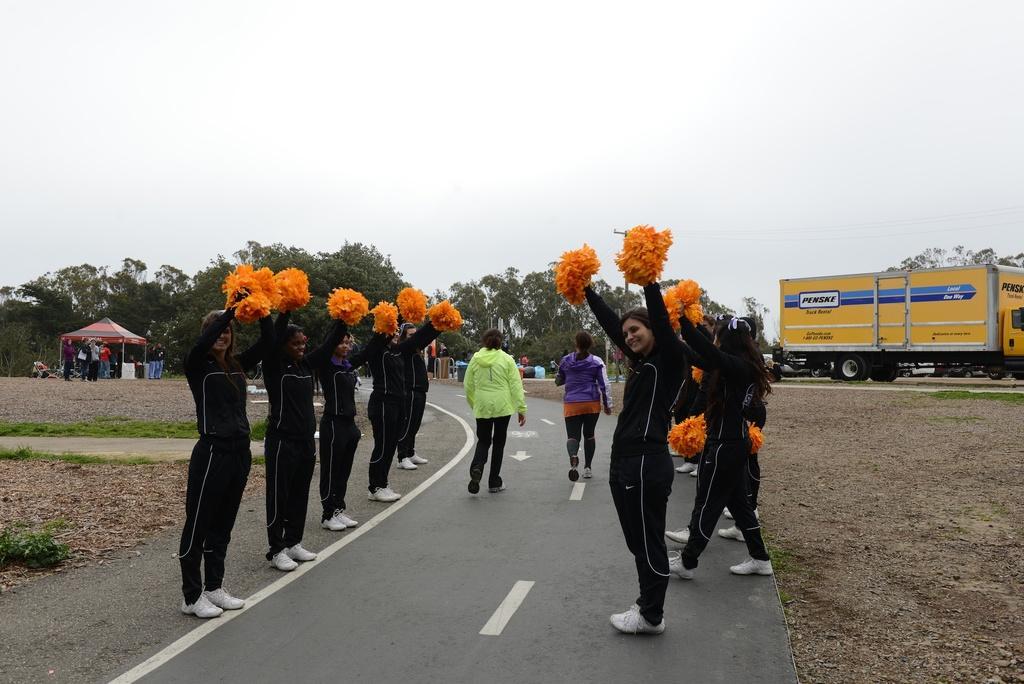In one or two sentences, can you explain what this image depicts? This is the picture of outside of the city. In this image there are group of people standing and holding the cheer poms and there are two persons walking on the road. On the left side of the image there are group of people standing under the tent. On the right side of the image there is a truck and there are some other vehicles. At the back there are trees. At the top there is sky. At the bottom there is a road and there is grass and mud. 